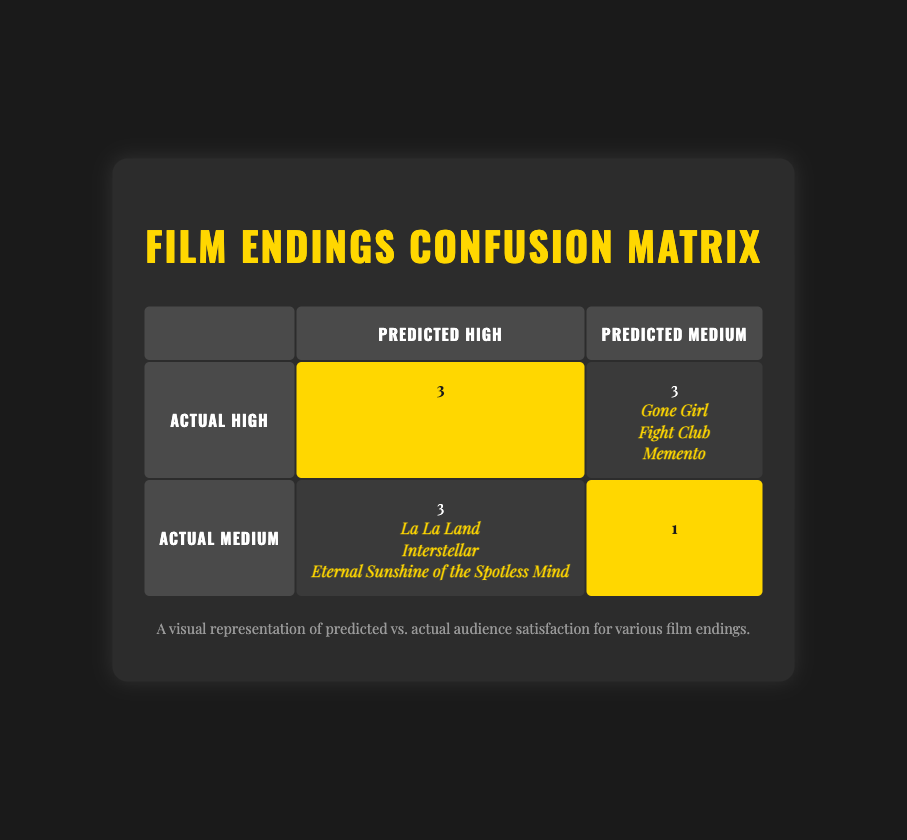What percentage of films predicted to have high satisfaction actually achieved high satisfaction? There are 6 films predicted to have high satisfaction. From the table, we see that 3 of these films (Inception, The Departed, and The Sixth Sense) actually achieved high satisfaction. Therefore, the percentage is (3/6) * 100 = 50%.
Answer: 50% Which film had the most significant difference between predicted and actual satisfaction? By examining the table, La La Land had a predicted satisfaction level of high, but the actual level was medium, representing a downward shift. Similarly, Interstellar predicted high and actual medium. The greatest upward shift is observed with Gone Girl, predicted medium and actual high. Between these, the downward shifts are considered as larger deviations, positioning La La Land as the most significant.
Answer: La La Land How many films achieved actual medium satisfaction? To determine this, I count the films listed under the "Actual Medium" row in the table. They are La La Land, Interstellar, and Eternal Sunshine of the Spotless Mind (3 films).
Answer: 3 Is it true that all films with medium predicted satisfaction had high actual satisfaction? Here, I refer to the "Predicted Medium" column, which shows three films: Birdman (actual medium), Gone Girl, and Fight Club (both actual high). Since Birdman’s actual satisfaction is medium, the statement is false.
Answer: No What is the relationship between predicted high satisfaction films and their actual ratings based on the table? Looking at the expected high ratings, I check how many achieved actual high satisfaction. Out of 5 films predicted high, 3 achieved high, 2 achieved medium. This indicates that a significant amount (60%) met expectations but also shows that some films did not reach the predicted high, suggesting a disparity.
Answer: 3 out of 5 films met expectations 